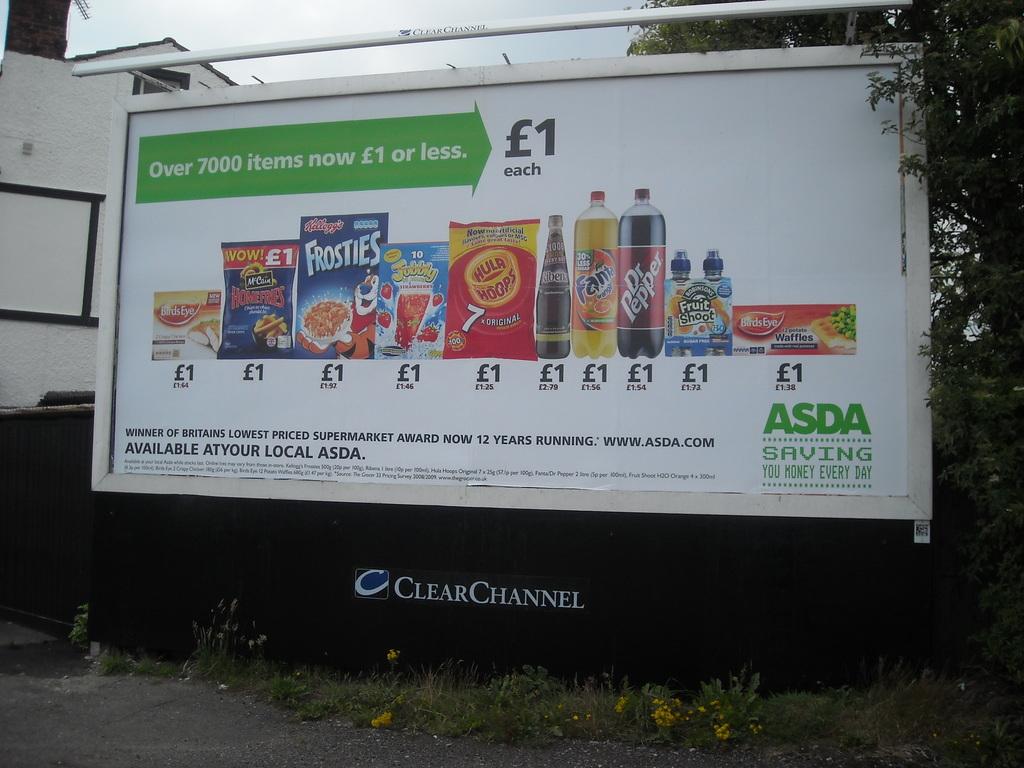Where can i see a list of all asda savings products?
Keep it short and to the point. Www.asda.com. How much does each item cost?
Offer a terse response. 1. 